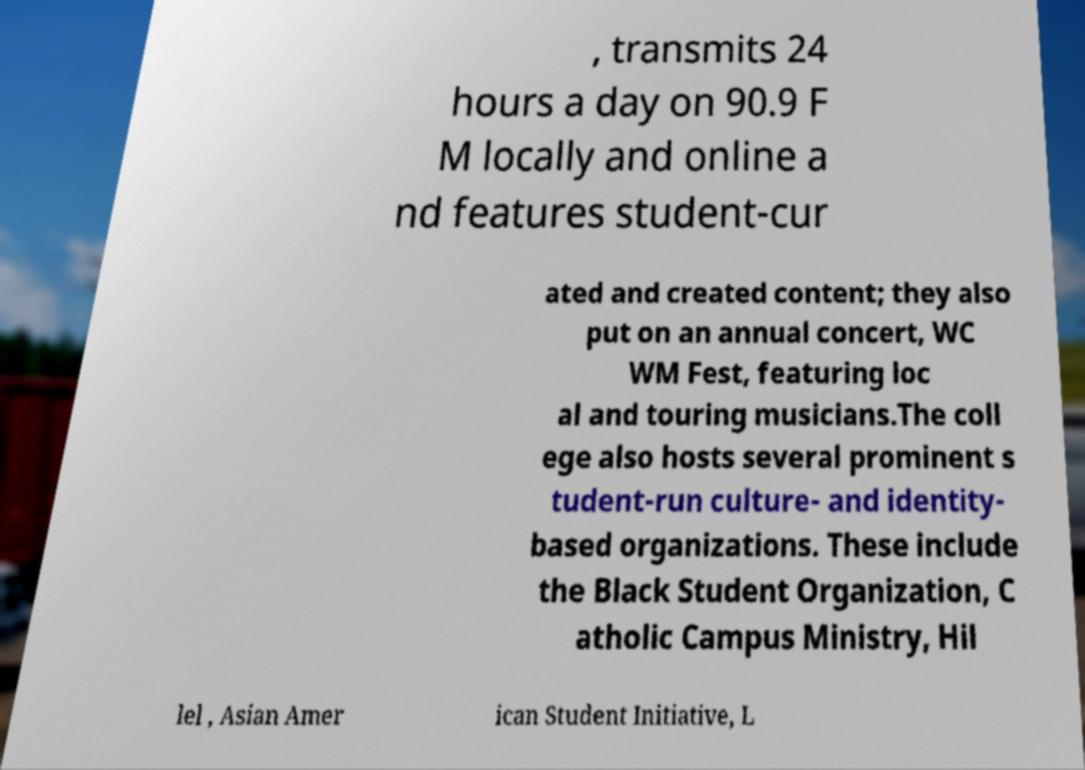I need the written content from this picture converted into text. Can you do that? , transmits 24 hours a day on 90.9 F M locally and online a nd features student-cur ated and created content; they also put on an annual concert, WC WM Fest, featuring loc al and touring musicians.The coll ege also hosts several prominent s tudent-run culture- and identity- based organizations. These include the Black Student Organization, C atholic Campus Ministry, Hil lel , Asian Amer ican Student Initiative, L 